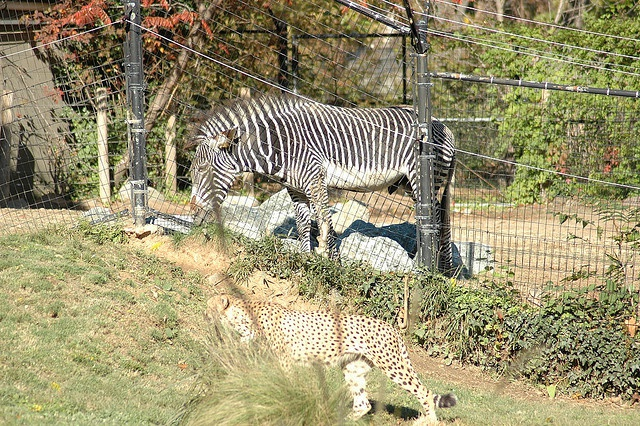Describe the objects in this image and their specific colors. I can see a zebra in black, ivory, gray, and darkgray tones in this image. 